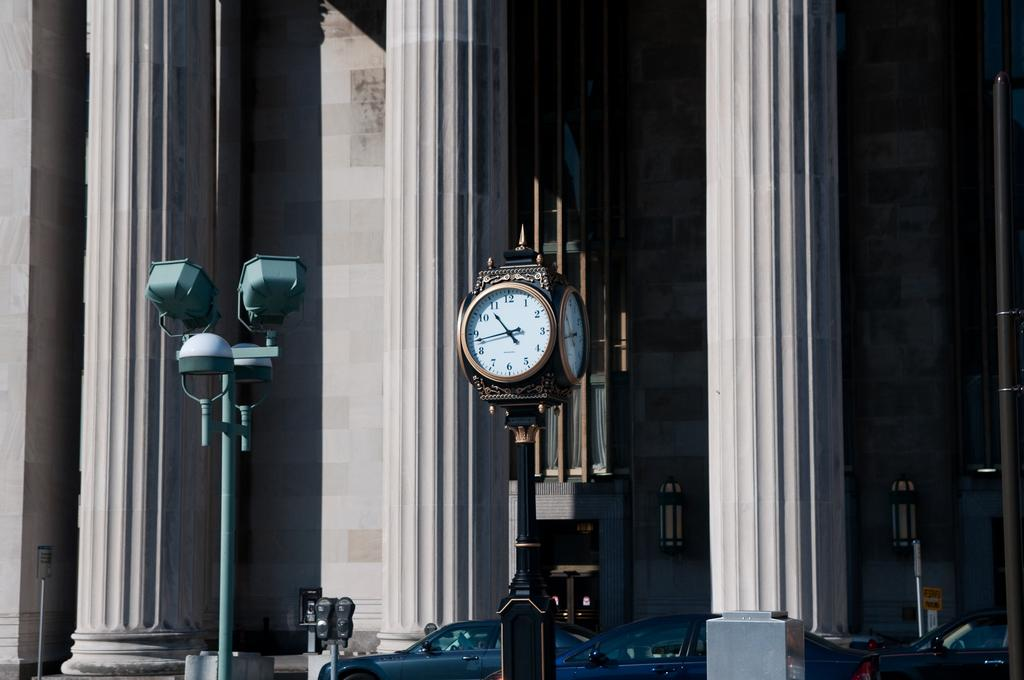Provide a one-sentence caption for the provided image. A square clock that says 10:43 is on a post in front of a building with large columns in front. 